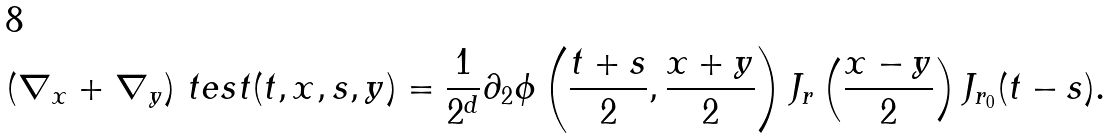<formula> <loc_0><loc_0><loc_500><loc_500>( \nabla _ { x } + \nabla _ { y } ) \ t e s t ( t , x , s , y ) = \frac { 1 } { 2 ^ { d } } \partial _ { 2 } \phi \left ( \frac { t + s } { 2 } , \frac { x + y } { 2 } \right ) J _ { r } \left ( \frac { x - y } { 2 } \right ) J _ { r _ { 0 } } ( t - s ) .</formula> 